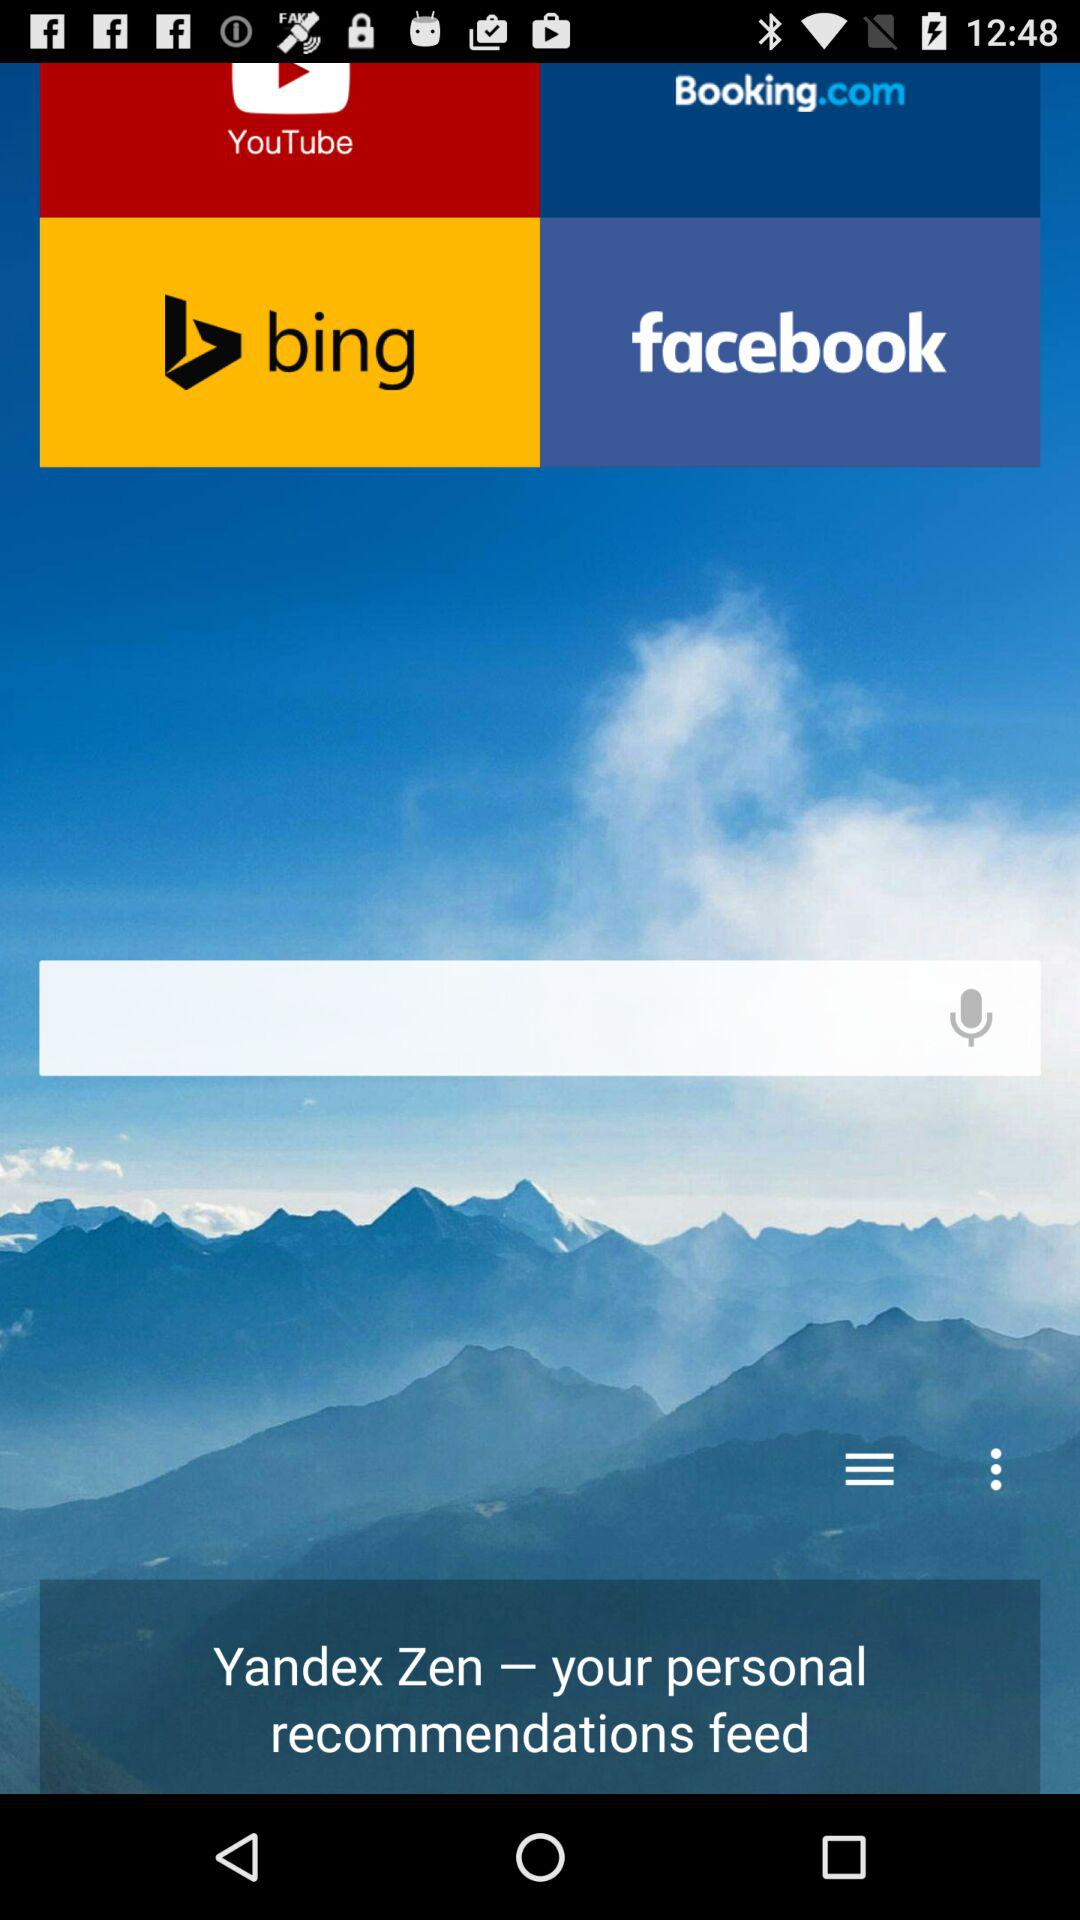What are the given application options? The given application options are "YouTube", "Booking.com", "bing" and "facebook". 